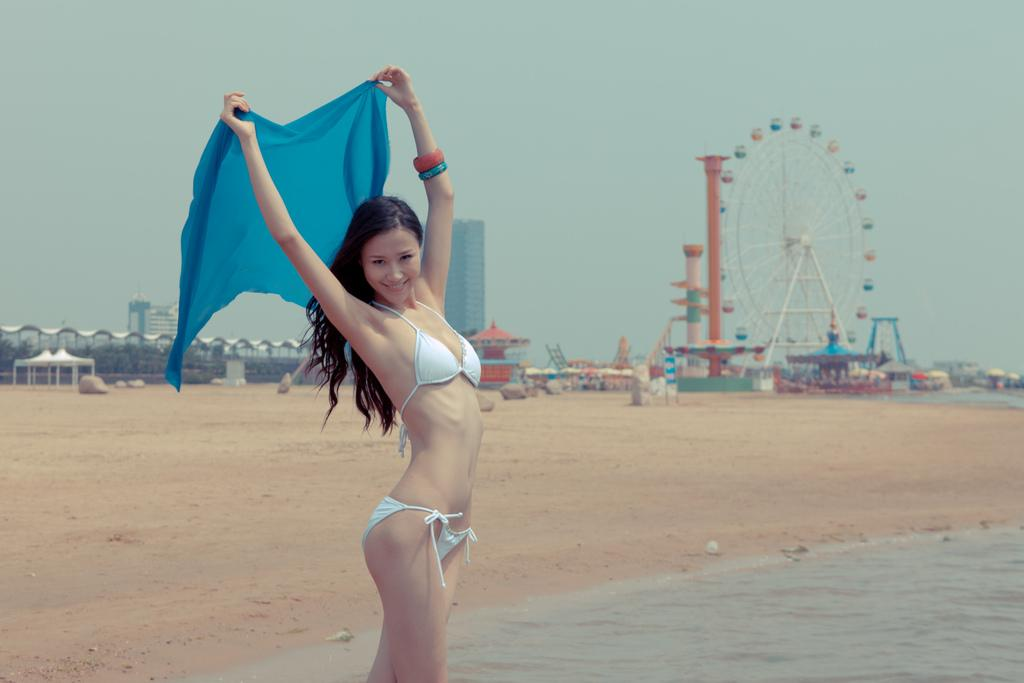What is the woman in the image doing? The woman is standing on the beach. How close is the woman to the water? The woman is near the water. What can be seen in the background of the image? There is a giant wheel, a pillar, buildings, and the sky visible in the background. How many rows of corn can be seen growing in the image? There is no corn visible in the image; it is set on a beach with a different background. 